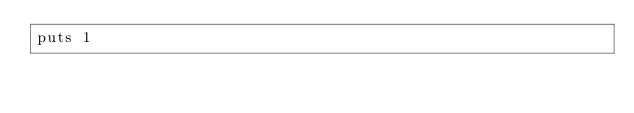Convert code to text. <code><loc_0><loc_0><loc_500><loc_500><_Ruby_>puts 1</code> 